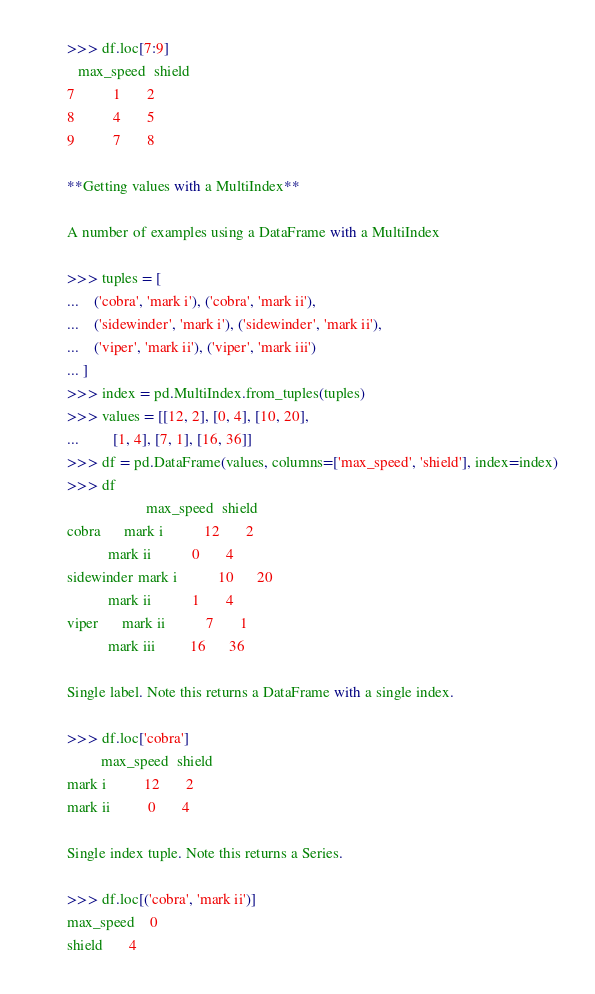Convert code to text. <code><loc_0><loc_0><loc_500><loc_500><_Python_>
        >>> df.loc[7:9]
           max_speed  shield
        7          1       2
        8          4       5
        9          7       8

        **Getting values with a MultiIndex**

        A number of examples using a DataFrame with a MultiIndex

        >>> tuples = [
        ...    ('cobra', 'mark i'), ('cobra', 'mark ii'),
        ...    ('sidewinder', 'mark i'), ('sidewinder', 'mark ii'),
        ...    ('viper', 'mark ii'), ('viper', 'mark iii')
        ... ]
        >>> index = pd.MultiIndex.from_tuples(tuples)
        >>> values = [[12, 2], [0, 4], [10, 20],
        ...         [1, 4], [7, 1], [16, 36]]
        >>> df = pd.DataFrame(values, columns=['max_speed', 'shield'], index=index)
        >>> df
                             max_speed  shield
        cobra      mark i           12       2
                   mark ii           0       4
        sidewinder mark i           10      20
                   mark ii           1       4
        viper      mark ii           7       1
                   mark iii         16      36

        Single label. Note this returns a DataFrame with a single index.

        >>> df.loc['cobra']
                 max_speed  shield
        mark i          12       2
        mark ii          0       4

        Single index tuple. Note this returns a Series.

        >>> df.loc[('cobra', 'mark ii')]
        max_speed    0
        shield       4</code> 